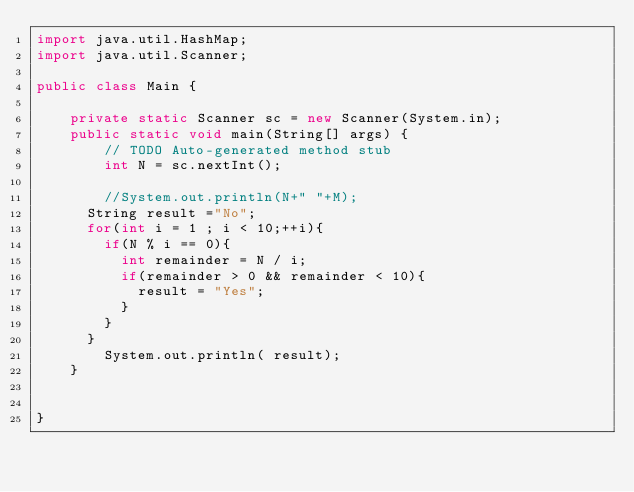<code> <loc_0><loc_0><loc_500><loc_500><_Java_>import java.util.HashMap;
import java.util.Scanner;

public class Main {

    private static Scanner sc = new Scanner(System.in);
    public static void main(String[] args) {
        // TODO Auto-generated method stub
        int N = sc.nextInt();
        
		//System.out.println(N+" "+M);
      String result ="No";
      for(int i = 1 ; i < 10;++i){
        if(N % i == 0){
          int remainder = N / i; 
          if(remainder > 0 && remainder < 10){
          	result = "Yes";
          } 
        }
      }
		System.out.println( result);
    }


}
</code> 